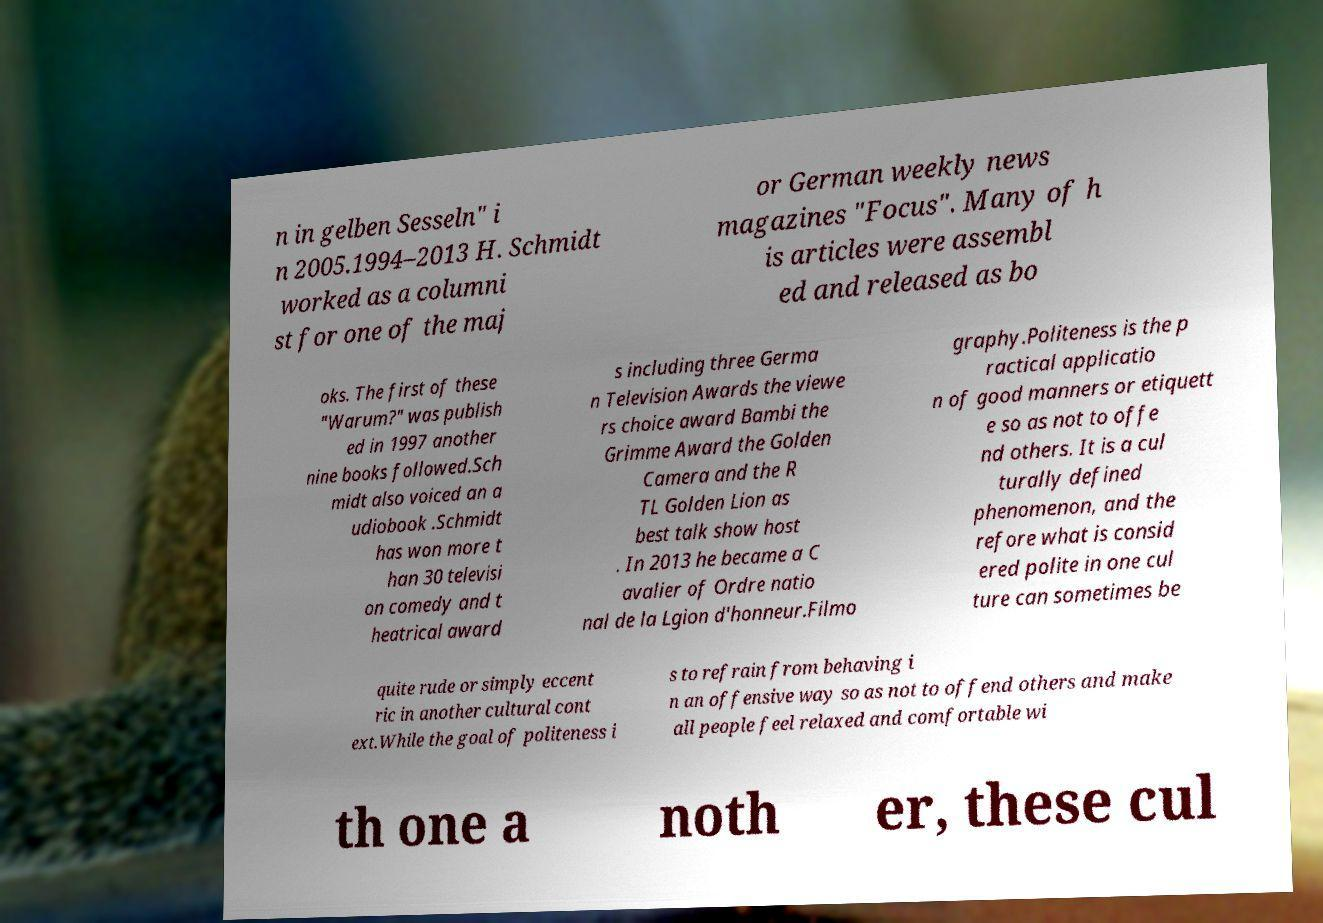Please read and relay the text visible in this image. What does it say? n in gelben Sesseln" i n 2005.1994–2013 H. Schmidt worked as a columni st for one of the maj or German weekly news magazines "Focus". Many of h is articles were assembl ed and released as bo oks. The first of these "Warum?" was publish ed in 1997 another nine books followed.Sch midt also voiced an a udiobook .Schmidt has won more t han 30 televisi on comedy and t heatrical award s including three Germa n Television Awards the viewe rs choice award Bambi the Grimme Award the Golden Camera and the R TL Golden Lion as best talk show host . In 2013 he became a C avalier of Ordre natio nal de la Lgion d'honneur.Filmo graphy.Politeness is the p ractical applicatio n of good manners or etiquett e so as not to offe nd others. It is a cul turally defined phenomenon, and the refore what is consid ered polite in one cul ture can sometimes be quite rude or simply eccent ric in another cultural cont ext.While the goal of politeness i s to refrain from behaving i n an offensive way so as not to offend others and make all people feel relaxed and comfortable wi th one a noth er, these cul 